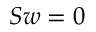<formula> <loc_0><loc_0><loc_500><loc_500>S w = 0</formula> 